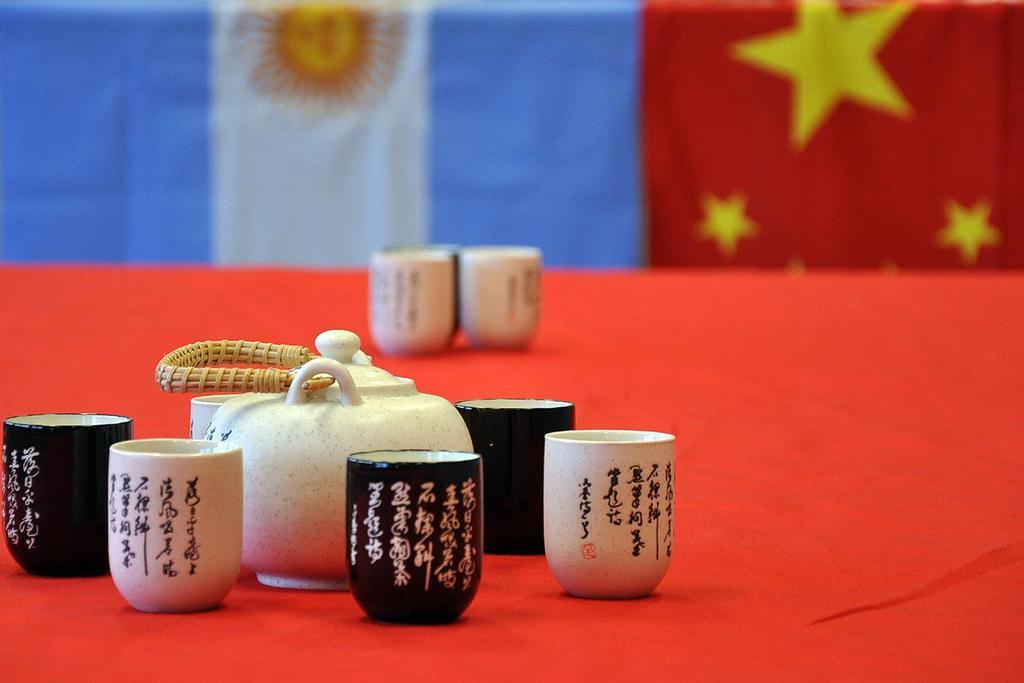What can be seen in the image that represents a symbol or country? There are flags in the image. What piece of furniture is present in the image? There is a table in the image. What objects are on the table? There are glasses on the table. How does the steam rise from the glasses on the table? There is no steam present in the image; the glasses are not hot or filled with any substance that would produce steam. 